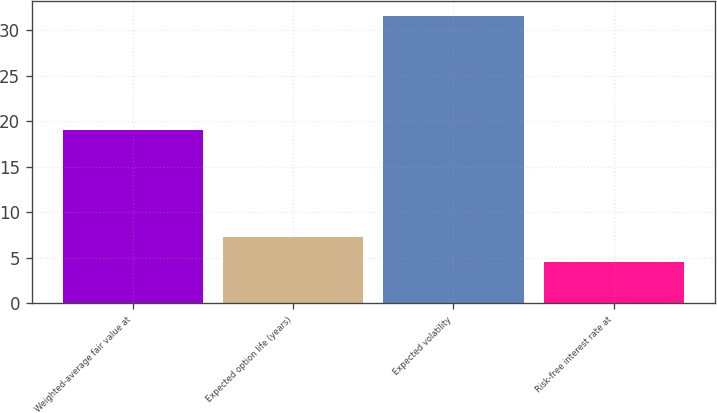Convert chart to OTSL. <chart><loc_0><loc_0><loc_500><loc_500><bar_chart><fcel>Weighted-average fair value at<fcel>Expected option life (years)<fcel>Expected volatility<fcel>Risk-free interest rate at<nl><fcel>19.1<fcel>7.3<fcel>31.6<fcel>4.6<nl></chart> 